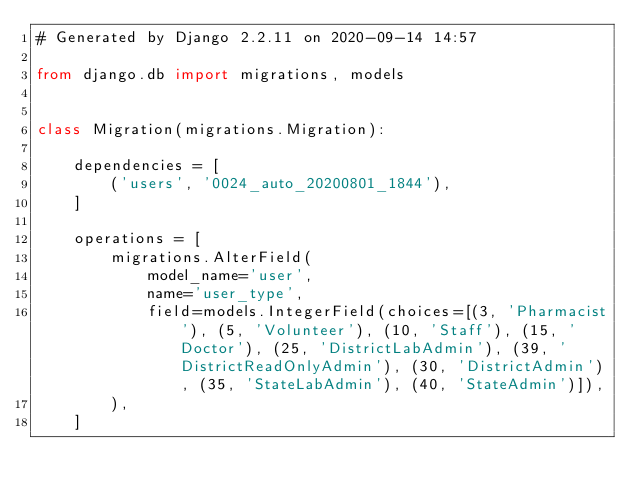Convert code to text. <code><loc_0><loc_0><loc_500><loc_500><_Python_># Generated by Django 2.2.11 on 2020-09-14 14:57

from django.db import migrations, models


class Migration(migrations.Migration):

    dependencies = [
        ('users', '0024_auto_20200801_1844'),
    ]

    operations = [
        migrations.AlterField(
            model_name='user',
            name='user_type',
            field=models.IntegerField(choices=[(3, 'Pharmacist'), (5, 'Volunteer'), (10, 'Staff'), (15, 'Doctor'), (25, 'DistrictLabAdmin'), (39, 'DistrictReadOnlyAdmin'), (30, 'DistrictAdmin'), (35, 'StateLabAdmin'), (40, 'StateAdmin')]),
        ),
    ]
</code> 